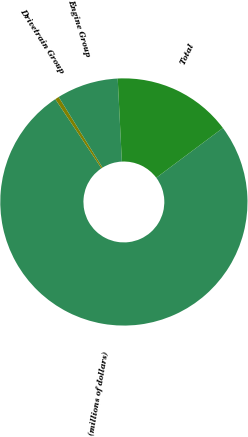<chart> <loc_0><loc_0><loc_500><loc_500><pie_chart><fcel>(millions of dollars)<fcel>Drivetrain Group<fcel>Engine Group<fcel>Total<nl><fcel>75.85%<fcel>0.52%<fcel>8.05%<fcel>15.58%<nl></chart> 